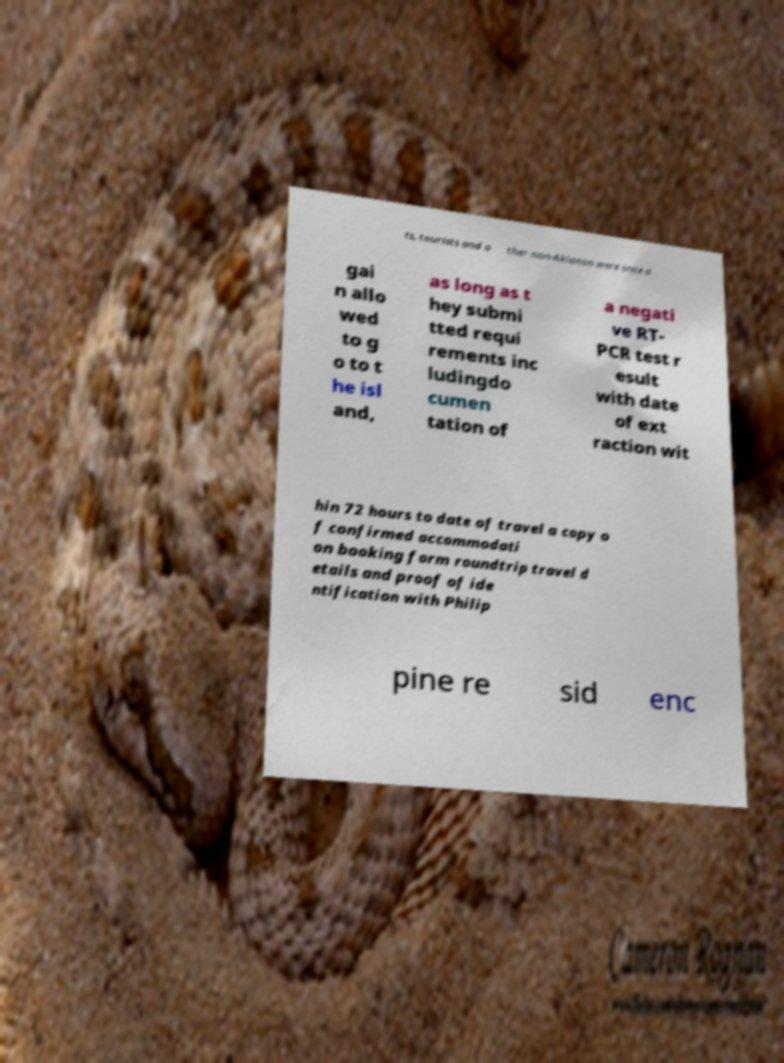Could you assist in decoding the text presented in this image and type it out clearly? ts, tourists and o ther non-Aklanon were once a gai n allo wed to g o to t he isl and, as long as t hey submi tted requi rements inc ludingdo cumen tation of a negati ve RT- PCR test r esult with date of ext raction wit hin 72 hours to date of travel a copy o f confirmed accommodati on booking form roundtrip travel d etails and proof of ide ntification with Philip pine re sid enc 